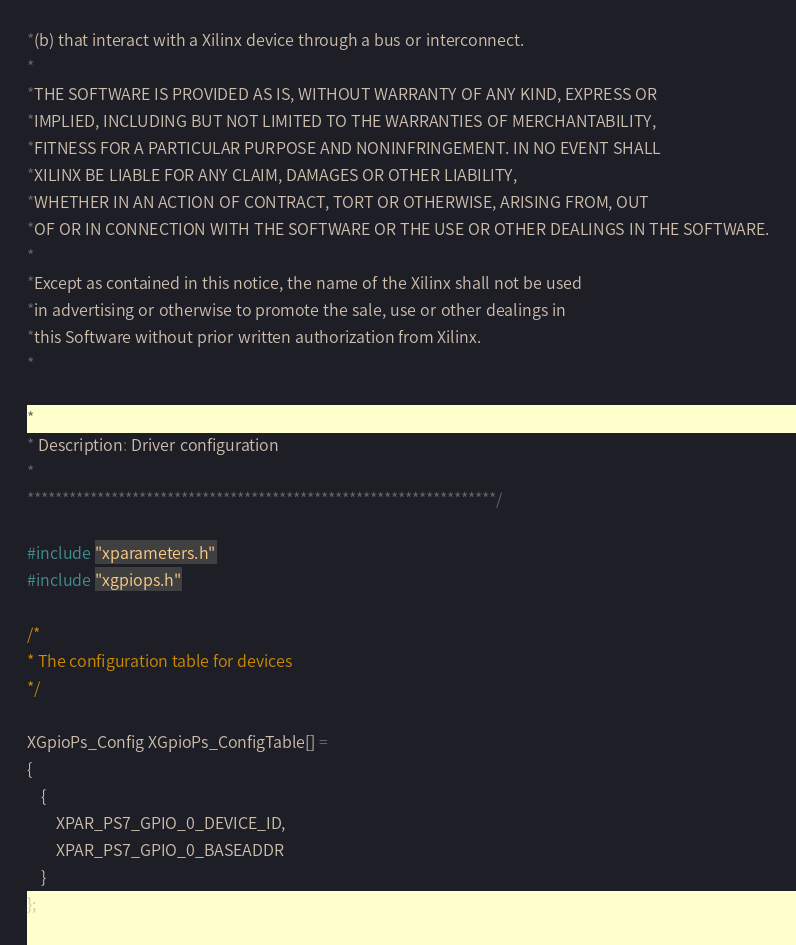Convert code to text. <code><loc_0><loc_0><loc_500><loc_500><_C_>*(b) that interact with a Xilinx device through a bus or interconnect.
*
*THE SOFTWARE IS PROVIDED AS IS, WITHOUT WARRANTY OF ANY KIND, EXPRESS OR
*IMPLIED, INCLUDING BUT NOT LIMITED TO THE WARRANTIES OF MERCHANTABILITY,
*FITNESS FOR A PARTICULAR PURPOSE AND NONINFRINGEMENT. IN NO EVENT SHALL 
*XILINX BE LIABLE FOR ANY CLAIM, DAMAGES OR OTHER LIABILITY,
*WHETHER IN AN ACTION OF CONTRACT, TORT OR OTHERWISE, ARISING FROM, OUT
*OF OR IN CONNECTION WITH THE SOFTWARE OR THE USE OR OTHER DEALINGS IN THE SOFTWARE.
*
*Except as contained in this notice, the name of the Xilinx shall not be used
*in advertising or otherwise to promote the sale, use or other dealings in
*this Software without prior written authorization from Xilinx.
*

* 
* Description: Driver configuration
*
*******************************************************************/

#include "xparameters.h"
#include "xgpiops.h"

/*
* The configuration table for devices
*/

XGpioPs_Config XGpioPs_ConfigTable[] =
{
	{
		XPAR_PS7_GPIO_0_DEVICE_ID,
		XPAR_PS7_GPIO_0_BASEADDR
	}
};


</code> 